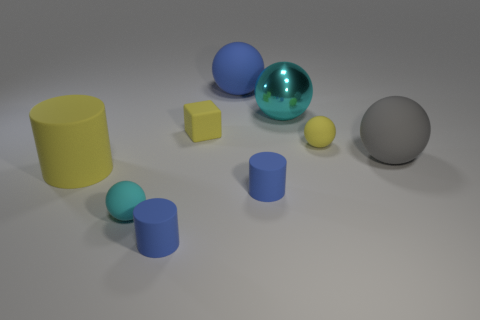Is there anything else that is the same material as the yellow block?
Make the answer very short. Yes. How many other things are there of the same color as the big metal object?
Your answer should be compact. 1. What material is the small cube?
Ensure brevity in your answer.  Rubber. What is the material of the big object that is both on the right side of the large blue ball and in front of the big cyan shiny sphere?
Provide a short and direct response. Rubber. How many objects are blue rubber objects that are behind the small yellow rubber sphere or small blue cylinders?
Provide a short and direct response. 3. Does the big cylinder have the same color as the metal object?
Provide a short and direct response. No. Are there any blue rubber spheres that have the same size as the yellow matte cube?
Make the answer very short. No. How many large things are in front of the large blue matte object and behind the tiny yellow cube?
Provide a succinct answer. 1. What number of tiny cyan objects are behind the cyan shiny ball?
Offer a terse response. 0. Is there a yellow matte thing of the same shape as the large blue matte object?
Provide a short and direct response. Yes. 